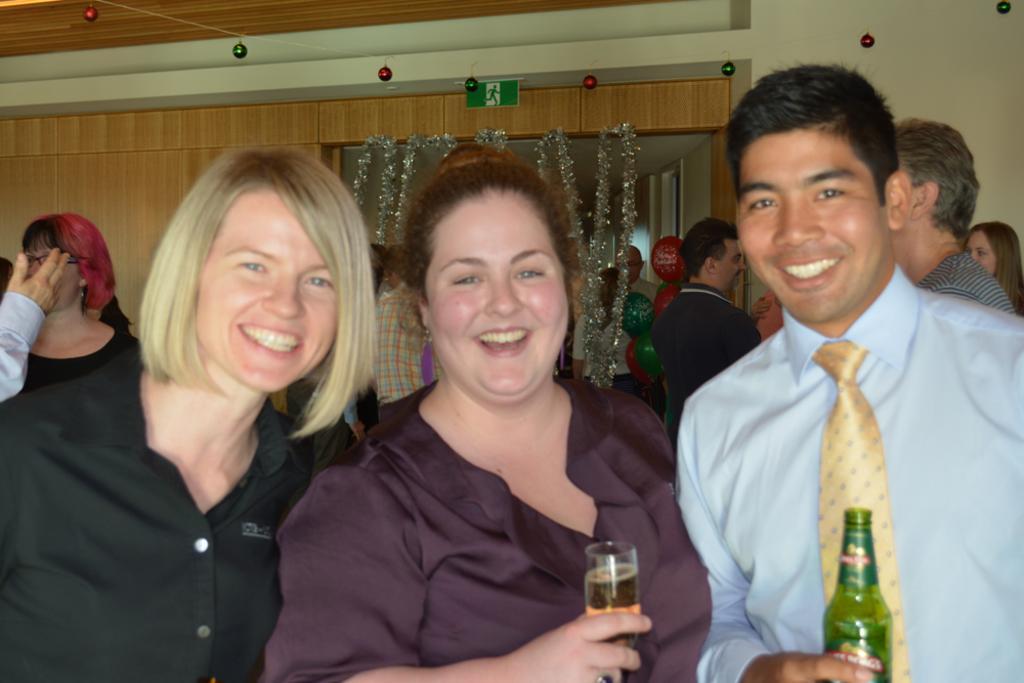Can you describe this image briefly? In this image I see 2 women in which one of them is holding the glass and a man over here is holding a bottle in his hand and I can also see that these 3 are smiling. In the background I see lot of people, decorations over here and the wall. 